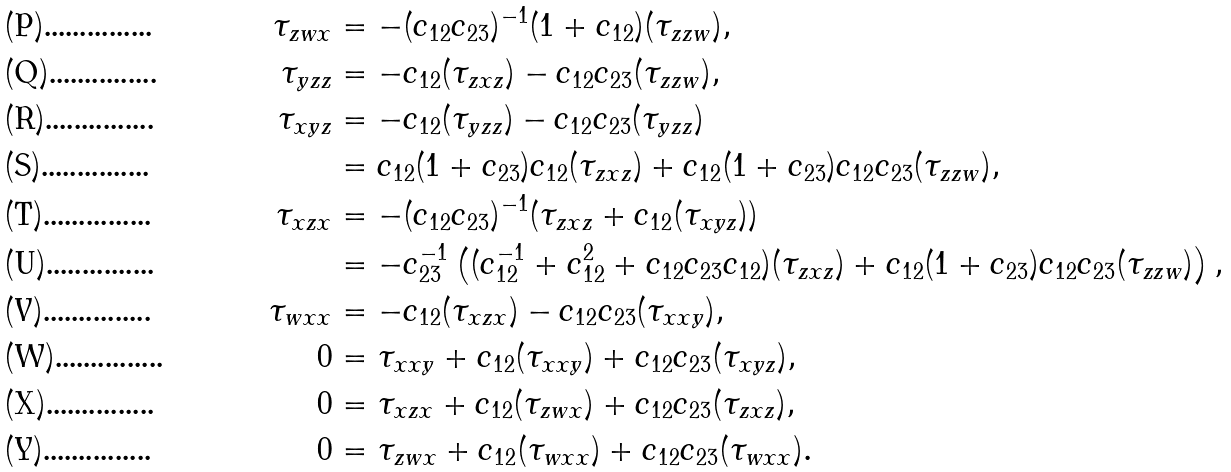<formula> <loc_0><loc_0><loc_500><loc_500>\tau _ { z w x } & = - ( c _ { 1 2 } c _ { 2 3 } ) ^ { - 1 } ( 1 + c _ { 1 2 } ) ( \tau _ { z z w } ) , \\ \tau _ { y z z } & = - c _ { 1 2 } ( \tau _ { z x z } ) - c _ { 1 2 } c _ { 2 3 } ( \tau _ { z z w } ) , \\ \tau _ { x y z } & = - c _ { 1 2 } ( \tau _ { y z z } ) - c _ { 1 2 } c _ { 2 3 } ( \tau _ { y z z } ) \\ & = c _ { 1 2 } ( 1 + c _ { 2 3 } ) c _ { 1 2 } ( \tau _ { z x z } ) + c _ { 1 2 } ( 1 + c _ { 2 3 } ) c _ { 1 2 } c _ { 2 3 } ( \tau _ { z z w } ) , \\ \tau _ { x z x } & = - ( c _ { 1 2 } c _ { 2 3 } ) ^ { - 1 } ( \tau _ { z x z } + c _ { 1 2 } ( \tau _ { x y z } ) ) \\ & = - c _ { 2 3 } ^ { - 1 } \left ( ( c _ { 1 2 } ^ { - 1 } + c _ { 1 2 } ^ { 2 } + c _ { 1 2 } c _ { 2 3 } c _ { 1 2 } ) ( \tau _ { z x z } ) + c _ { 1 2 } ( 1 + c _ { 2 3 } ) c _ { 1 2 } c _ { 2 3 } ( \tau _ { z z w } ) \right ) , \\ \tau _ { w x x } & = - c _ { 1 2 } ( \tau _ { x z x } ) - c _ { 1 2 } c _ { 2 3 } ( \tau _ { x x y } ) , \\ 0 & = \tau _ { x x y } + c _ { 1 2 } ( \tau _ { x x y } ) + c _ { 1 2 } c _ { 2 3 } ( \tau _ { x y z } ) , \\ 0 & = \tau _ { x z x } + c _ { 1 2 } ( \tau _ { z w x } ) + c _ { 1 2 } c _ { 2 3 } ( \tau _ { z x z } ) , \\ 0 & = \tau _ { z w x } + c _ { 1 2 } ( \tau _ { w x x } ) + c _ { 1 2 } c _ { 2 3 } ( \tau _ { w x x } ) .</formula> 